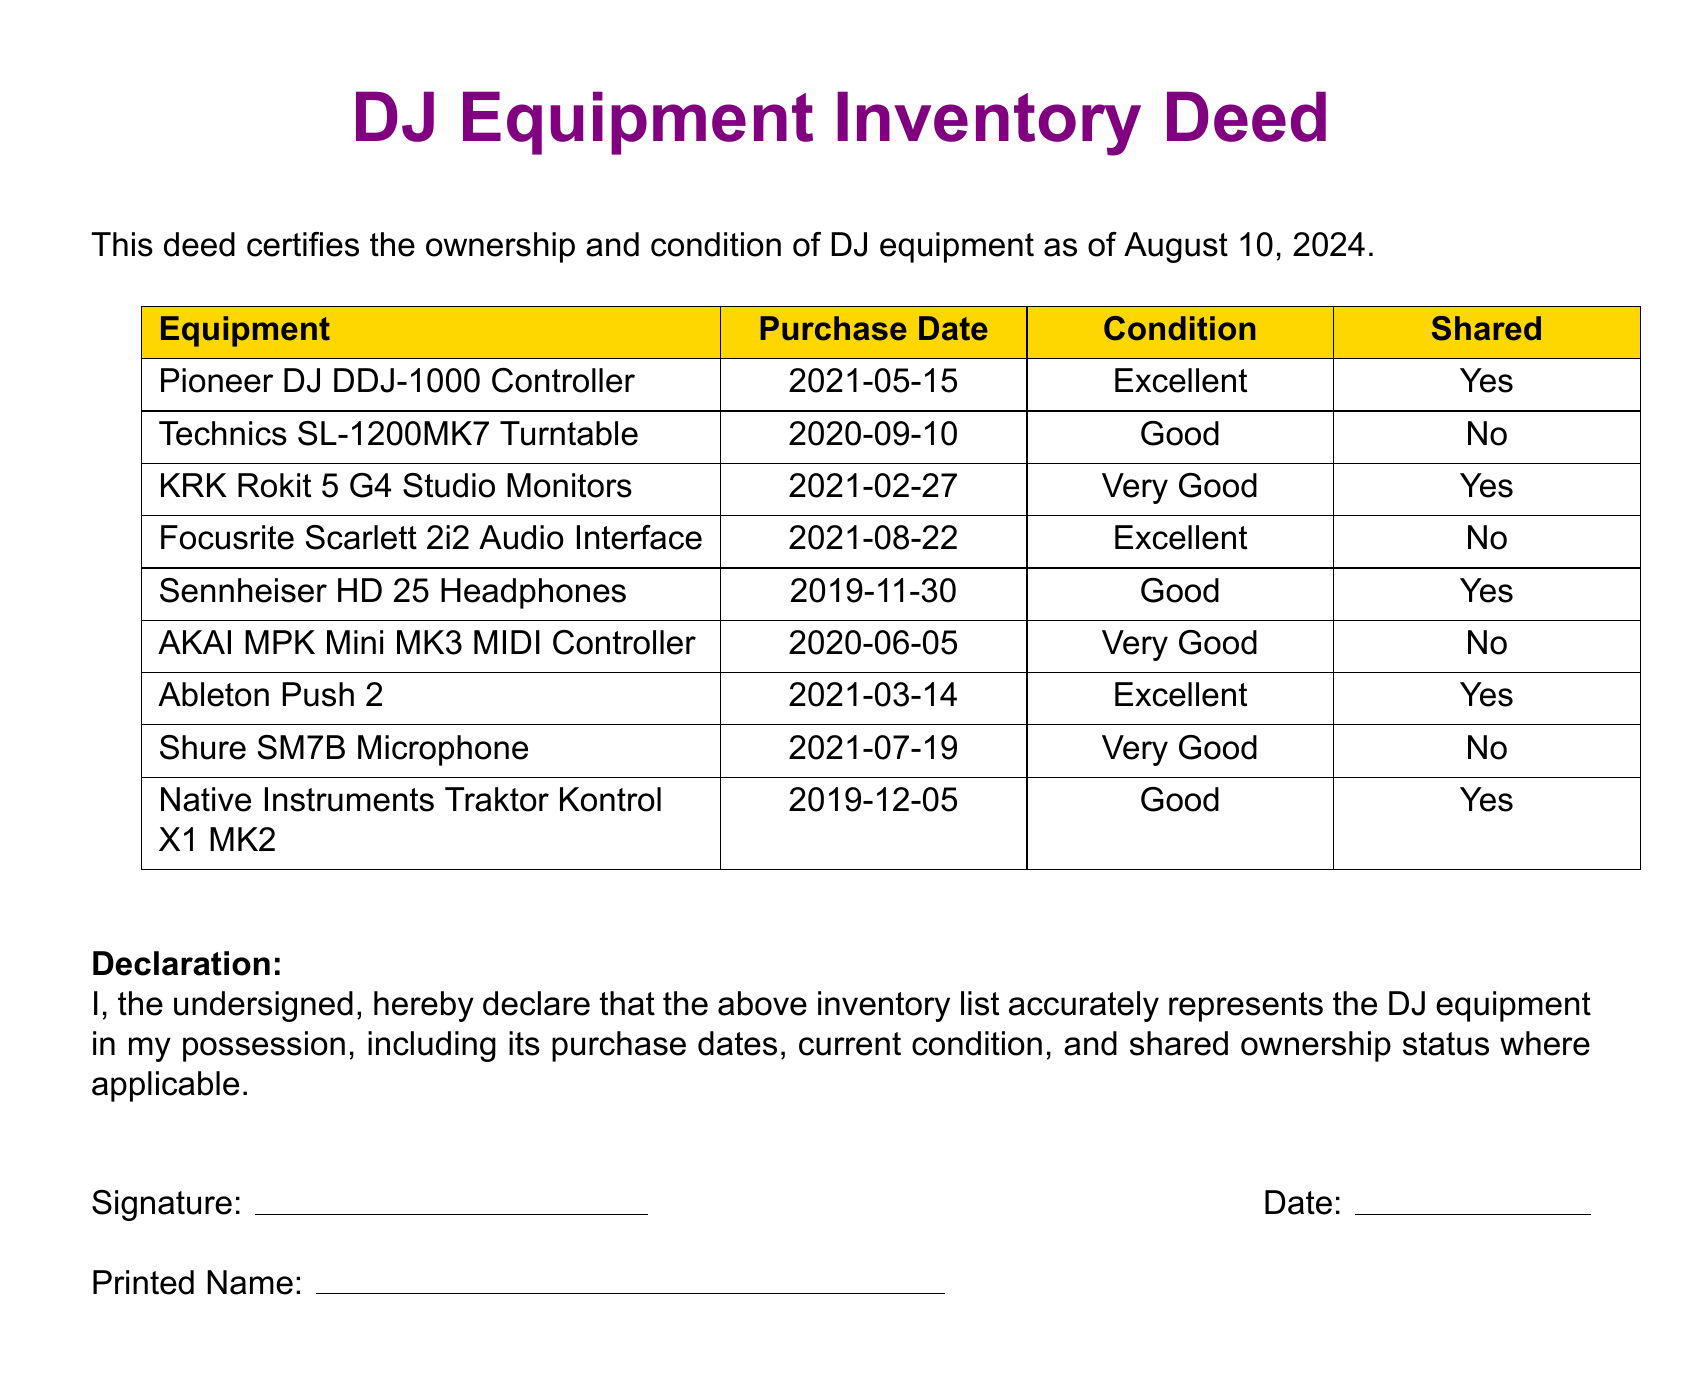What is the title of the document? The title, highlighted in the center, indicates the contents of the document as the DJ Equipment Inventory Deed.
Answer: DJ Equipment Inventory Deed How many pieces of equipment are listed? The document shows a table containing a total of 10 equipment entries.
Answer: 10 What is the purchase date of the Pioneer DJ DDJ-1000 Controller? The table lists the purchase date corresponding to the Pioneer DJ DDJ-1000 as May 15, 2021.
Answer: 2021-05-15 Which equipment is in 'Excellent' condition? By reviewing the 'Condition' column, the equipment items in 'Excellent' condition include the Pioneer DJ DDJ-1000 Controller, Focusrite Scarlett 2i2 Audio Interface, and Ableton Push 2.
Answer: Pioneer DJ DDJ-1000 Controller, Focusrite Scarlett 2i2 Audio Interface, Ableton Push 2 Is the AKAI MPK Mini MK3 MIDI Controller shared? The 'Shared' status in the table indicates the ownership status of the AKAI MPK Mini MK3 MIDI Controller. It is marked as 'No'.
Answer: No What equipment has a purchase date listed in 2020? The inventory lists the Technics SL-1200MK7 Turntable and AKAI MPK Mini MK3 MIDI Controller as the equipment purchased in 2020.
Answer: Technics SL-1200MK7 Turntable, AKAI MPK Mini MK3 MIDI Controller What is noted about the Sennheiser HD 25 Headphones? The document marks the Sennheiser HD 25 Headphones’ condition and shared status, indicating they are in 'Good' condition and are 'Yes' for shared ownership.
Answer: Good, Yes Who is responsible for the accuracy of the inventory list? The declaration section of the document indicates that the undersigned is responsible for certifying the inventory's accuracy.
Answer: The undersigned 